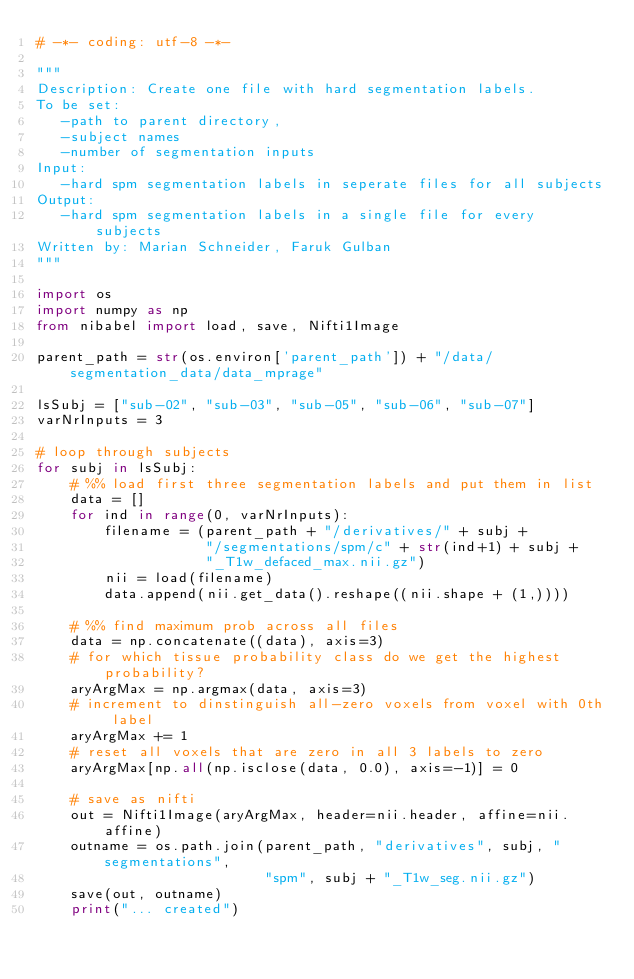Convert code to text. <code><loc_0><loc_0><loc_500><loc_500><_Python_># -*- coding: utf-8 -*-

"""
Description: Create one file with hard segmentation labels.
To be set:
   -path to parent directory,
   -subject names
   -number of segmentation inputs
Input:
   -hard spm segmentation labels in seperate files for all subjects
Output:
   -hard spm segmentation labels in a single file for every subjects
Written by: Marian Schneider, Faruk Gulban
"""

import os
import numpy as np
from nibabel import load, save, Nifti1Image

parent_path = str(os.environ['parent_path']) + "/data/segmentation_data/data_mprage"

lsSubj = ["sub-02", "sub-03", "sub-05", "sub-06", "sub-07"]
varNrInputs = 3

# loop through subjects
for subj in lsSubj:
    # %% load first three segmentation labels and put them in list
    data = []
    for ind in range(0, varNrInputs):
        filename = (parent_path + "/derivatives/" + subj +
                    "/segmentations/spm/c" + str(ind+1) + subj +
                    "_T1w_defaced_max.nii.gz")
        nii = load(filename)
        data.append(nii.get_data().reshape((nii.shape + (1,))))

    # %% find maximum prob across all files
    data = np.concatenate((data), axis=3)
    # for which tissue probability class do we get the highest probability?
    aryArgMax = np.argmax(data, axis=3)
    # increment to dinstinguish all-zero voxels from voxel with 0th label
    aryArgMax += 1
    # reset all voxels that are zero in all 3 labels to zero
    aryArgMax[np.all(np.isclose(data, 0.0), axis=-1)] = 0

    # save as nifti
    out = Nifti1Image(aryArgMax, header=nii.header, affine=nii.affine)
    outname = os.path.join(parent_path, "derivatives", subj, "segmentations",
                           "spm", subj + "_T1w_seg.nii.gz")
    save(out, outname)
    print("... created")
</code> 